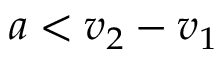<formula> <loc_0><loc_0><loc_500><loc_500>a < v _ { 2 } - v _ { 1 }</formula> 